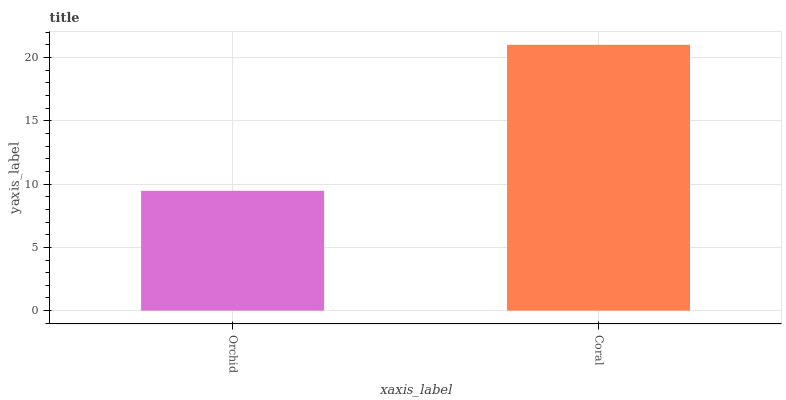Is Orchid the minimum?
Answer yes or no. Yes. Is Coral the maximum?
Answer yes or no. Yes. Is Coral the minimum?
Answer yes or no. No. Is Coral greater than Orchid?
Answer yes or no. Yes. Is Orchid less than Coral?
Answer yes or no. Yes. Is Orchid greater than Coral?
Answer yes or no. No. Is Coral less than Orchid?
Answer yes or no. No. Is Coral the high median?
Answer yes or no. Yes. Is Orchid the low median?
Answer yes or no. Yes. Is Orchid the high median?
Answer yes or no. No. Is Coral the low median?
Answer yes or no. No. 